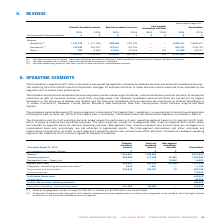According to Cogeco's financial document, Where is the activities of Canadian broadband services carried out? According to the financial document, Québec and Ontario. The relevant text states: "rried out by Cogeco Connexion in the provinces of Québec and Ontario and the American broadband services activities are carried out by Atlantic Broadband in 11 states:..." Also, Where is the activities of American broadband services carried out? 11 states: Connecticut, Delaware, Florida, Maine, Maryland, New Hampshire, New York, Pennsylvania, South Carolina, Virginia and West Virginia.. The document states: "ctivities are carried out by Atlantic Broadband in 11 states: Connecticut, Delaware, Florida, Maine, Maryland, New Hampshire, New York, Pennsylvania, ..." Also, What are the services provided by Canadian and American broadband? a wide range of Internet, video and telephony services primarily to residential customers as well as business services across their coverage areas. The document states: "and American broadband services segments provide a wide range of Internet, video and telephony services primarily to residential customers as well as ..." Also, can you calculate: What is the average Revenue between Canadian and American broadband services for year ended August 31, 2019? To answer this question, I need to perform calculations using the financial data. The calculation is: (1,294,967+1,036,853)/ 2, which equals 1165910 (in thousands). This is based on the information: "Revenue (1) 1,294,967 1,036,853 — 2,331,820 Revenue (1) 1,294,967 1,036,853 — 2,331,820..." The key data points involved are: 1,036,853, 1,294,967. Also, can you calculate: What are the average Operating expenses from Canadian and American broadband services for year ended August 31, 2019? To answer this question, I need to perform calculations using the financial data. The calculation is: (606,286+571,208 ) / 2, which equals 588747 (in thousands). This is based on the information: "Operating expenses 606,286 571,208 26,486 1,203,980 Operating expenses 606,286 571,208 26,486 1,203,980..." The key data points involved are: 571,208, 606,286. Also, can you calculate: What is the average Integration, restructuring and acquisition costs from Canadian and American broadband services for year ended August 31, 2019? To answer this question, I need to perform calculations using the financial data. The calculation is: (9,299+1,851) / 2, which equals 5575 (in thousands). This is based on the information: "on, restructuring and acquisition costs (2) 9,299 1,851 — 11,150 egration, restructuring and acquisition costs (2) 9,299 1,851 — 11,150..." The key data points involved are: 1,851, 9,299. 